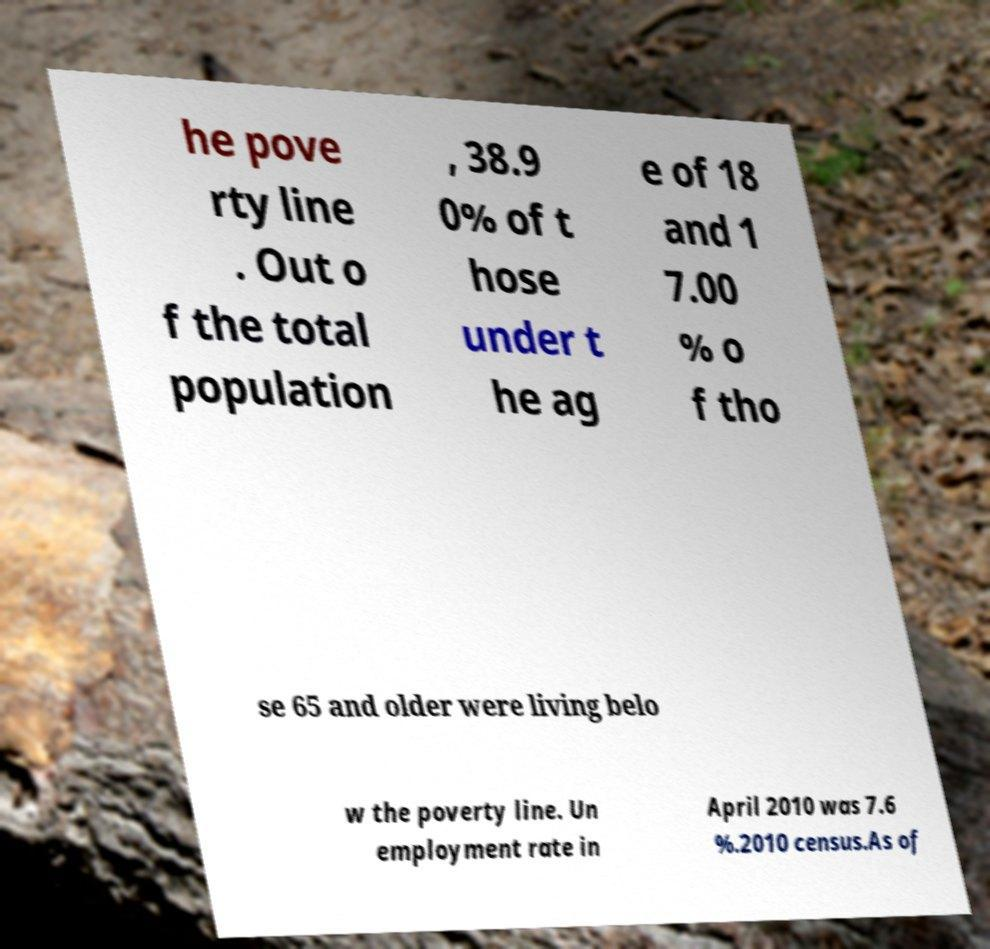There's text embedded in this image that I need extracted. Can you transcribe it verbatim? he pove rty line . Out o f the total population , 38.9 0% of t hose under t he ag e of 18 and 1 7.00 % o f tho se 65 and older were living belo w the poverty line. Un employment rate in April 2010 was 7.6 %.2010 census.As of 